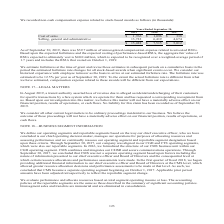According to Cubic's financial document, What was the forfeiture rate estimated to be? 12.5% per year as of September 30, 2019. The document states: "ure rate. The forfeiture rate was estimated to be 12.5% per year as of September 30, 2019. To the extent the actual forfeiture rate is different from ..." Also, What is total non-cash compensation expense related to stock-based awards in 2019? According to the financial document, $15,488 (in thousands). The relevant text states: "$ 15,488 $ 7,515 $ 5,012..." Also, For which years is the amount of non-cash compensation expense related to stock-based awards recorded? The document contains multiple relevant values: 2019, 2018, 2017. From the document: "Years Ended September 30, 2019 2018 2017 Years Ended September 30, 2019 2018 2017 Years Ended September 30, 2019 2018 2017..." Additionally, In which year was the amount of cost of sales the largest? According to the financial document, 2019. The relevant text states: "Years Ended September 30, 2019 2018 2017..." Also, can you calculate: What is the change in cost of sales in 2019 from 2018? Based on the calculation: 1,766-1,096, the result is 670 (in thousands). This is based on the information: "Cost of sales $ 1,766 $ 1,096 $ 338 Cost of sales $ 1,766 $ 1,096 $ 338..." The key data points involved are: 1,096, 1,766. Also, can you calculate: What is the percentage change in cost of sales in 2019 from 2018? To answer this question, I need to perform calculations using the financial data. The calculation is: (1,766-1,096)/1,096, which equals 61.13 (percentage). This is based on the information: "Cost of sales $ 1,766 $ 1,096 $ 338 Cost of sales $ 1,766 $ 1,096 $ 338..." The key data points involved are: 1,096, 1,766. 